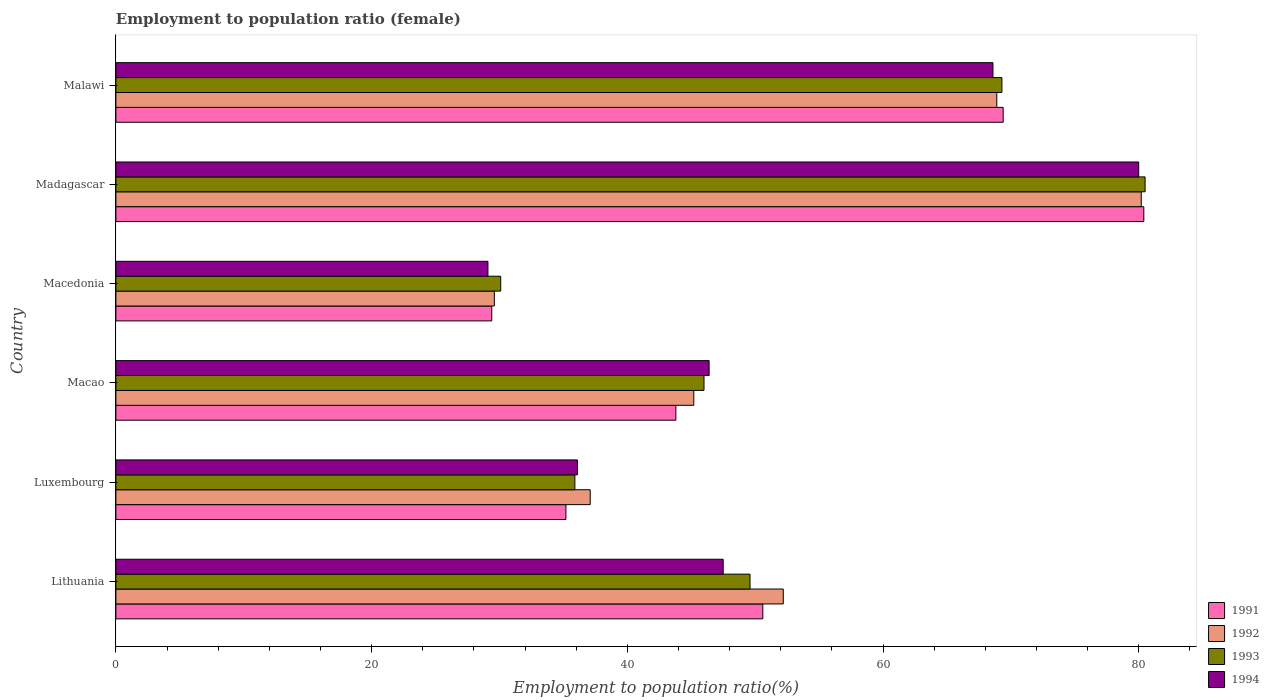How many different coloured bars are there?
Offer a terse response. 4. What is the label of the 1st group of bars from the top?
Offer a terse response. Malawi. In how many cases, is the number of bars for a given country not equal to the number of legend labels?
Provide a succinct answer. 0. What is the employment to population ratio in 1993 in Luxembourg?
Provide a short and direct response. 35.9. Across all countries, what is the maximum employment to population ratio in 1994?
Give a very brief answer. 80. Across all countries, what is the minimum employment to population ratio in 1993?
Provide a short and direct response. 30.1. In which country was the employment to population ratio in 1994 maximum?
Your response must be concise. Madagascar. In which country was the employment to population ratio in 1994 minimum?
Your response must be concise. Macedonia. What is the total employment to population ratio in 1991 in the graph?
Your answer should be compact. 308.8. What is the difference between the employment to population ratio in 1994 in Lithuania and that in Luxembourg?
Make the answer very short. 11.4. What is the difference between the employment to population ratio in 1992 in Macao and the employment to population ratio in 1991 in Luxembourg?
Give a very brief answer. 10. What is the average employment to population ratio in 1991 per country?
Ensure brevity in your answer.  51.47. What is the difference between the employment to population ratio in 1993 and employment to population ratio in 1992 in Madagascar?
Provide a short and direct response. 0.3. In how many countries, is the employment to population ratio in 1994 greater than 28 %?
Offer a terse response. 6. What is the ratio of the employment to population ratio in 1993 in Macao to that in Madagascar?
Give a very brief answer. 0.57. What is the difference between the highest and the second highest employment to population ratio in 1994?
Keep it short and to the point. 11.4. What is the difference between the highest and the lowest employment to population ratio in 1994?
Give a very brief answer. 50.9. Is the sum of the employment to population ratio in 1993 in Macao and Malawi greater than the maximum employment to population ratio in 1992 across all countries?
Give a very brief answer. Yes. Is it the case that in every country, the sum of the employment to population ratio in 1992 and employment to population ratio in 1993 is greater than the sum of employment to population ratio in 1994 and employment to population ratio in 1991?
Make the answer very short. No. Is it the case that in every country, the sum of the employment to population ratio in 1991 and employment to population ratio in 1994 is greater than the employment to population ratio in 1992?
Provide a succinct answer. Yes. How many bars are there?
Give a very brief answer. 24. Are all the bars in the graph horizontal?
Keep it short and to the point. Yes. How many countries are there in the graph?
Ensure brevity in your answer.  6. Are the values on the major ticks of X-axis written in scientific E-notation?
Your answer should be compact. No. Does the graph contain any zero values?
Offer a terse response. No. Does the graph contain grids?
Keep it short and to the point. No. What is the title of the graph?
Make the answer very short. Employment to population ratio (female). What is the Employment to population ratio(%) in 1991 in Lithuania?
Your response must be concise. 50.6. What is the Employment to population ratio(%) of 1992 in Lithuania?
Your response must be concise. 52.2. What is the Employment to population ratio(%) in 1993 in Lithuania?
Keep it short and to the point. 49.6. What is the Employment to population ratio(%) of 1994 in Lithuania?
Make the answer very short. 47.5. What is the Employment to population ratio(%) in 1991 in Luxembourg?
Keep it short and to the point. 35.2. What is the Employment to population ratio(%) of 1992 in Luxembourg?
Provide a short and direct response. 37.1. What is the Employment to population ratio(%) in 1993 in Luxembourg?
Make the answer very short. 35.9. What is the Employment to population ratio(%) of 1994 in Luxembourg?
Your answer should be very brief. 36.1. What is the Employment to population ratio(%) of 1991 in Macao?
Ensure brevity in your answer.  43.8. What is the Employment to population ratio(%) in 1992 in Macao?
Your answer should be compact. 45.2. What is the Employment to population ratio(%) of 1993 in Macao?
Ensure brevity in your answer.  46. What is the Employment to population ratio(%) in 1994 in Macao?
Ensure brevity in your answer.  46.4. What is the Employment to population ratio(%) in 1991 in Macedonia?
Provide a succinct answer. 29.4. What is the Employment to population ratio(%) in 1992 in Macedonia?
Your answer should be compact. 29.6. What is the Employment to population ratio(%) of 1993 in Macedonia?
Give a very brief answer. 30.1. What is the Employment to population ratio(%) of 1994 in Macedonia?
Make the answer very short. 29.1. What is the Employment to population ratio(%) in 1991 in Madagascar?
Offer a very short reply. 80.4. What is the Employment to population ratio(%) of 1992 in Madagascar?
Your response must be concise. 80.2. What is the Employment to population ratio(%) of 1993 in Madagascar?
Provide a short and direct response. 80.5. What is the Employment to population ratio(%) of 1994 in Madagascar?
Provide a short and direct response. 80. What is the Employment to population ratio(%) of 1991 in Malawi?
Make the answer very short. 69.4. What is the Employment to population ratio(%) in 1992 in Malawi?
Offer a very short reply. 68.9. What is the Employment to population ratio(%) of 1993 in Malawi?
Provide a succinct answer. 69.3. What is the Employment to population ratio(%) in 1994 in Malawi?
Give a very brief answer. 68.6. Across all countries, what is the maximum Employment to population ratio(%) of 1991?
Offer a very short reply. 80.4. Across all countries, what is the maximum Employment to population ratio(%) of 1992?
Ensure brevity in your answer.  80.2. Across all countries, what is the maximum Employment to population ratio(%) in 1993?
Your response must be concise. 80.5. Across all countries, what is the minimum Employment to population ratio(%) of 1991?
Your response must be concise. 29.4. Across all countries, what is the minimum Employment to population ratio(%) of 1992?
Your answer should be compact. 29.6. Across all countries, what is the minimum Employment to population ratio(%) in 1993?
Your answer should be very brief. 30.1. Across all countries, what is the minimum Employment to population ratio(%) of 1994?
Keep it short and to the point. 29.1. What is the total Employment to population ratio(%) in 1991 in the graph?
Provide a succinct answer. 308.8. What is the total Employment to population ratio(%) in 1992 in the graph?
Give a very brief answer. 313.2. What is the total Employment to population ratio(%) of 1993 in the graph?
Offer a very short reply. 311.4. What is the total Employment to population ratio(%) in 1994 in the graph?
Give a very brief answer. 307.7. What is the difference between the Employment to population ratio(%) of 1991 in Lithuania and that in Luxembourg?
Provide a succinct answer. 15.4. What is the difference between the Employment to population ratio(%) of 1994 in Lithuania and that in Luxembourg?
Your answer should be compact. 11.4. What is the difference between the Employment to population ratio(%) of 1992 in Lithuania and that in Macao?
Offer a very short reply. 7. What is the difference between the Employment to population ratio(%) of 1991 in Lithuania and that in Macedonia?
Your answer should be very brief. 21.2. What is the difference between the Employment to population ratio(%) of 1992 in Lithuania and that in Macedonia?
Offer a very short reply. 22.6. What is the difference between the Employment to population ratio(%) in 1993 in Lithuania and that in Macedonia?
Offer a very short reply. 19.5. What is the difference between the Employment to population ratio(%) of 1994 in Lithuania and that in Macedonia?
Keep it short and to the point. 18.4. What is the difference between the Employment to population ratio(%) in 1991 in Lithuania and that in Madagascar?
Keep it short and to the point. -29.8. What is the difference between the Employment to population ratio(%) of 1993 in Lithuania and that in Madagascar?
Offer a very short reply. -30.9. What is the difference between the Employment to population ratio(%) of 1994 in Lithuania and that in Madagascar?
Keep it short and to the point. -32.5. What is the difference between the Employment to population ratio(%) of 1991 in Lithuania and that in Malawi?
Offer a very short reply. -18.8. What is the difference between the Employment to population ratio(%) in 1992 in Lithuania and that in Malawi?
Provide a short and direct response. -16.7. What is the difference between the Employment to population ratio(%) in 1993 in Lithuania and that in Malawi?
Provide a short and direct response. -19.7. What is the difference between the Employment to population ratio(%) of 1994 in Lithuania and that in Malawi?
Ensure brevity in your answer.  -21.1. What is the difference between the Employment to population ratio(%) of 1992 in Luxembourg and that in Macao?
Make the answer very short. -8.1. What is the difference between the Employment to population ratio(%) in 1993 in Luxembourg and that in Macao?
Ensure brevity in your answer.  -10.1. What is the difference between the Employment to population ratio(%) of 1994 in Luxembourg and that in Macao?
Ensure brevity in your answer.  -10.3. What is the difference between the Employment to population ratio(%) in 1991 in Luxembourg and that in Macedonia?
Your answer should be compact. 5.8. What is the difference between the Employment to population ratio(%) in 1991 in Luxembourg and that in Madagascar?
Provide a short and direct response. -45.2. What is the difference between the Employment to population ratio(%) in 1992 in Luxembourg and that in Madagascar?
Your answer should be very brief. -43.1. What is the difference between the Employment to population ratio(%) in 1993 in Luxembourg and that in Madagascar?
Your answer should be very brief. -44.6. What is the difference between the Employment to population ratio(%) of 1994 in Luxembourg and that in Madagascar?
Ensure brevity in your answer.  -43.9. What is the difference between the Employment to population ratio(%) of 1991 in Luxembourg and that in Malawi?
Your answer should be very brief. -34.2. What is the difference between the Employment to population ratio(%) in 1992 in Luxembourg and that in Malawi?
Give a very brief answer. -31.8. What is the difference between the Employment to population ratio(%) in 1993 in Luxembourg and that in Malawi?
Offer a terse response. -33.4. What is the difference between the Employment to population ratio(%) of 1994 in Luxembourg and that in Malawi?
Your answer should be very brief. -32.5. What is the difference between the Employment to population ratio(%) in 1994 in Macao and that in Macedonia?
Offer a very short reply. 17.3. What is the difference between the Employment to population ratio(%) of 1991 in Macao and that in Madagascar?
Your response must be concise. -36.6. What is the difference between the Employment to population ratio(%) in 1992 in Macao and that in Madagascar?
Provide a succinct answer. -35. What is the difference between the Employment to population ratio(%) of 1993 in Macao and that in Madagascar?
Your answer should be compact. -34.5. What is the difference between the Employment to population ratio(%) in 1994 in Macao and that in Madagascar?
Your answer should be compact. -33.6. What is the difference between the Employment to population ratio(%) in 1991 in Macao and that in Malawi?
Your response must be concise. -25.6. What is the difference between the Employment to population ratio(%) of 1992 in Macao and that in Malawi?
Give a very brief answer. -23.7. What is the difference between the Employment to population ratio(%) of 1993 in Macao and that in Malawi?
Make the answer very short. -23.3. What is the difference between the Employment to population ratio(%) in 1994 in Macao and that in Malawi?
Make the answer very short. -22.2. What is the difference between the Employment to population ratio(%) in 1991 in Macedonia and that in Madagascar?
Provide a short and direct response. -51. What is the difference between the Employment to population ratio(%) in 1992 in Macedonia and that in Madagascar?
Provide a short and direct response. -50.6. What is the difference between the Employment to population ratio(%) of 1993 in Macedonia and that in Madagascar?
Give a very brief answer. -50.4. What is the difference between the Employment to population ratio(%) in 1994 in Macedonia and that in Madagascar?
Give a very brief answer. -50.9. What is the difference between the Employment to population ratio(%) of 1991 in Macedonia and that in Malawi?
Make the answer very short. -40. What is the difference between the Employment to population ratio(%) in 1992 in Macedonia and that in Malawi?
Ensure brevity in your answer.  -39.3. What is the difference between the Employment to population ratio(%) of 1993 in Macedonia and that in Malawi?
Give a very brief answer. -39.2. What is the difference between the Employment to population ratio(%) in 1994 in Macedonia and that in Malawi?
Your response must be concise. -39.5. What is the difference between the Employment to population ratio(%) of 1992 in Madagascar and that in Malawi?
Provide a short and direct response. 11.3. What is the difference between the Employment to population ratio(%) of 1994 in Madagascar and that in Malawi?
Provide a short and direct response. 11.4. What is the difference between the Employment to population ratio(%) of 1991 in Lithuania and the Employment to population ratio(%) of 1992 in Luxembourg?
Ensure brevity in your answer.  13.5. What is the difference between the Employment to population ratio(%) in 1991 in Lithuania and the Employment to population ratio(%) in 1993 in Luxembourg?
Your answer should be very brief. 14.7. What is the difference between the Employment to population ratio(%) of 1992 in Lithuania and the Employment to population ratio(%) of 1993 in Luxembourg?
Your answer should be very brief. 16.3. What is the difference between the Employment to population ratio(%) of 1992 in Lithuania and the Employment to population ratio(%) of 1994 in Luxembourg?
Offer a terse response. 16.1. What is the difference between the Employment to population ratio(%) of 1993 in Lithuania and the Employment to population ratio(%) of 1994 in Luxembourg?
Give a very brief answer. 13.5. What is the difference between the Employment to population ratio(%) in 1991 in Lithuania and the Employment to population ratio(%) in 1992 in Macao?
Ensure brevity in your answer.  5.4. What is the difference between the Employment to population ratio(%) of 1991 in Lithuania and the Employment to population ratio(%) of 1993 in Macao?
Make the answer very short. 4.6. What is the difference between the Employment to population ratio(%) of 1991 in Lithuania and the Employment to population ratio(%) of 1994 in Macao?
Ensure brevity in your answer.  4.2. What is the difference between the Employment to population ratio(%) of 1992 in Lithuania and the Employment to population ratio(%) of 1993 in Macao?
Ensure brevity in your answer.  6.2. What is the difference between the Employment to population ratio(%) of 1993 in Lithuania and the Employment to population ratio(%) of 1994 in Macao?
Provide a short and direct response. 3.2. What is the difference between the Employment to population ratio(%) in 1991 in Lithuania and the Employment to population ratio(%) in 1994 in Macedonia?
Keep it short and to the point. 21.5. What is the difference between the Employment to population ratio(%) of 1992 in Lithuania and the Employment to population ratio(%) of 1993 in Macedonia?
Give a very brief answer. 22.1. What is the difference between the Employment to population ratio(%) in 1992 in Lithuania and the Employment to population ratio(%) in 1994 in Macedonia?
Ensure brevity in your answer.  23.1. What is the difference between the Employment to population ratio(%) in 1991 in Lithuania and the Employment to population ratio(%) in 1992 in Madagascar?
Your answer should be compact. -29.6. What is the difference between the Employment to population ratio(%) in 1991 in Lithuania and the Employment to population ratio(%) in 1993 in Madagascar?
Your response must be concise. -29.9. What is the difference between the Employment to population ratio(%) in 1991 in Lithuania and the Employment to population ratio(%) in 1994 in Madagascar?
Provide a short and direct response. -29.4. What is the difference between the Employment to population ratio(%) of 1992 in Lithuania and the Employment to population ratio(%) of 1993 in Madagascar?
Offer a terse response. -28.3. What is the difference between the Employment to population ratio(%) in 1992 in Lithuania and the Employment to population ratio(%) in 1994 in Madagascar?
Provide a succinct answer. -27.8. What is the difference between the Employment to population ratio(%) of 1993 in Lithuania and the Employment to population ratio(%) of 1994 in Madagascar?
Offer a very short reply. -30.4. What is the difference between the Employment to population ratio(%) in 1991 in Lithuania and the Employment to population ratio(%) in 1992 in Malawi?
Give a very brief answer. -18.3. What is the difference between the Employment to population ratio(%) of 1991 in Lithuania and the Employment to population ratio(%) of 1993 in Malawi?
Offer a very short reply. -18.7. What is the difference between the Employment to population ratio(%) of 1991 in Lithuania and the Employment to population ratio(%) of 1994 in Malawi?
Offer a terse response. -18. What is the difference between the Employment to population ratio(%) in 1992 in Lithuania and the Employment to population ratio(%) in 1993 in Malawi?
Your answer should be very brief. -17.1. What is the difference between the Employment to population ratio(%) of 1992 in Lithuania and the Employment to population ratio(%) of 1994 in Malawi?
Give a very brief answer. -16.4. What is the difference between the Employment to population ratio(%) in 1993 in Lithuania and the Employment to population ratio(%) in 1994 in Malawi?
Your response must be concise. -19. What is the difference between the Employment to population ratio(%) in 1991 in Luxembourg and the Employment to population ratio(%) in 1993 in Macao?
Your answer should be very brief. -10.8. What is the difference between the Employment to population ratio(%) in 1991 in Luxembourg and the Employment to population ratio(%) in 1994 in Macao?
Your answer should be very brief. -11.2. What is the difference between the Employment to population ratio(%) in 1992 in Luxembourg and the Employment to population ratio(%) in 1993 in Macao?
Keep it short and to the point. -8.9. What is the difference between the Employment to population ratio(%) in 1991 in Luxembourg and the Employment to population ratio(%) in 1992 in Macedonia?
Give a very brief answer. 5.6. What is the difference between the Employment to population ratio(%) in 1991 in Luxembourg and the Employment to population ratio(%) in 1993 in Macedonia?
Offer a very short reply. 5.1. What is the difference between the Employment to population ratio(%) of 1991 in Luxembourg and the Employment to population ratio(%) of 1994 in Macedonia?
Give a very brief answer. 6.1. What is the difference between the Employment to population ratio(%) in 1992 in Luxembourg and the Employment to population ratio(%) in 1994 in Macedonia?
Make the answer very short. 8. What is the difference between the Employment to population ratio(%) of 1991 in Luxembourg and the Employment to population ratio(%) of 1992 in Madagascar?
Offer a terse response. -45. What is the difference between the Employment to population ratio(%) of 1991 in Luxembourg and the Employment to population ratio(%) of 1993 in Madagascar?
Provide a succinct answer. -45.3. What is the difference between the Employment to population ratio(%) in 1991 in Luxembourg and the Employment to population ratio(%) in 1994 in Madagascar?
Ensure brevity in your answer.  -44.8. What is the difference between the Employment to population ratio(%) of 1992 in Luxembourg and the Employment to population ratio(%) of 1993 in Madagascar?
Offer a very short reply. -43.4. What is the difference between the Employment to population ratio(%) of 1992 in Luxembourg and the Employment to population ratio(%) of 1994 in Madagascar?
Provide a succinct answer. -42.9. What is the difference between the Employment to population ratio(%) in 1993 in Luxembourg and the Employment to population ratio(%) in 1994 in Madagascar?
Keep it short and to the point. -44.1. What is the difference between the Employment to population ratio(%) in 1991 in Luxembourg and the Employment to population ratio(%) in 1992 in Malawi?
Give a very brief answer. -33.7. What is the difference between the Employment to population ratio(%) in 1991 in Luxembourg and the Employment to population ratio(%) in 1993 in Malawi?
Provide a short and direct response. -34.1. What is the difference between the Employment to population ratio(%) in 1991 in Luxembourg and the Employment to population ratio(%) in 1994 in Malawi?
Offer a very short reply. -33.4. What is the difference between the Employment to population ratio(%) of 1992 in Luxembourg and the Employment to population ratio(%) of 1993 in Malawi?
Ensure brevity in your answer.  -32.2. What is the difference between the Employment to population ratio(%) of 1992 in Luxembourg and the Employment to population ratio(%) of 1994 in Malawi?
Ensure brevity in your answer.  -31.5. What is the difference between the Employment to population ratio(%) of 1993 in Luxembourg and the Employment to population ratio(%) of 1994 in Malawi?
Provide a succinct answer. -32.7. What is the difference between the Employment to population ratio(%) of 1991 in Macao and the Employment to population ratio(%) of 1992 in Macedonia?
Offer a terse response. 14.2. What is the difference between the Employment to population ratio(%) of 1991 in Macao and the Employment to population ratio(%) of 1994 in Macedonia?
Keep it short and to the point. 14.7. What is the difference between the Employment to population ratio(%) of 1992 in Macao and the Employment to population ratio(%) of 1993 in Macedonia?
Offer a terse response. 15.1. What is the difference between the Employment to population ratio(%) in 1993 in Macao and the Employment to population ratio(%) in 1994 in Macedonia?
Keep it short and to the point. 16.9. What is the difference between the Employment to population ratio(%) of 1991 in Macao and the Employment to population ratio(%) of 1992 in Madagascar?
Offer a terse response. -36.4. What is the difference between the Employment to population ratio(%) of 1991 in Macao and the Employment to population ratio(%) of 1993 in Madagascar?
Provide a short and direct response. -36.7. What is the difference between the Employment to population ratio(%) of 1991 in Macao and the Employment to population ratio(%) of 1994 in Madagascar?
Your response must be concise. -36.2. What is the difference between the Employment to population ratio(%) in 1992 in Macao and the Employment to population ratio(%) in 1993 in Madagascar?
Make the answer very short. -35.3. What is the difference between the Employment to population ratio(%) of 1992 in Macao and the Employment to population ratio(%) of 1994 in Madagascar?
Offer a very short reply. -34.8. What is the difference between the Employment to population ratio(%) of 1993 in Macao and the Employment to population ratio(%) of 1994 in Madagascar?
Provide a short and direct response. -34. What is the difference between the Employment to population ratio(%) in 1991 in Macao and the Employment to population ratio(%) in 1992 in Malawi?
Provide a short and direct response. -25.1. What is the difference between the Employment to population ratio(%) in 1991 in Macao and the Employment to population ratio(%) in 1993 in Malawi?
Make the answer very short. -25.5. What is the difference between the Employment to population ratio(%) in 1991 in Macao and the Employment to population ratio(%) in 1994 in Malawi?
Provide a short and direct response. -24.8. What is the difference between the Employment to population ratio(%) of 1992 in Macao and the Employment to population ratio(%) of 1993 in Malawi?
Your response must be concise. -24.1. What is the difference between the Employment to population ratio(%) in 1992 in Macao and the Employment to population ratio(%) in 1994 in Malawi?
Your answer should be very brief. -23.4. What is the difference between the Employment to population ratio(%) in 1993 in Macao and the Employment to population ratio(%) in 1994 in Malawi?
Make the answer very short. -22.6. What is the difference between the Employment to population ratio(%) of 1991 in Macedonia and the Employment to population ratio(%) of 1992 in Madagascar?
Keep it short and to the point. -50.8. What is the difference between the Employment to population ratio(%) of 1991 in Macedonia and the Employment to population ratio(%) of 1993 in Madagascar?
Your answer should be compact. -51.1. What is the difference between the Employment to population ratio(%) of 1991 in Macedonia and the Employment to population ratio(%) of 1994 in Madagascar?
Give a very brief answer. -50.6. What is the difference between the Employment to population ratio(%) in 1992 in Macedonia and the Employment to population ratio(%) in 1993 in Madagascar?
Provide a succinct answer. -50.9. What is the difference between the Employment to population ratio(%) in 1992 in Macedonia and the Employment to population ratio(%) in 1994 in Madagascar?
Provide a short and direct response. -50.4. What is the difference between the Employment to population ratio(%) in 1993 in Macedonia and the Employment to population ratio(%) in 1994 in Madagascar?
Your answer should be very brief. -49.9. What is the difference between the Employment to population ratio(%) of 1991 in Macedonia and the Employment to population ratio(%) of 1992 in Malawi?
Offer a very short reply. -39.5. What is the difference between the Employment to population ratio(%) in 1991 in Macedonia and the Employment to population ratio(%) in 1993 in Malawi?
Ensure brevity in your answer.  -39.9. What is the difference between the Employment to population ratio(%) of 1991 in Macedonia and the Employment to population ratio(%) of 1994 in Malawi?
Give a very brief answer. -39.2. What is the difference between the Employment to population ratio(%) in 1992 in Macedonia and the Employment to population ratio(%) in 1993 in Malawi?
Your answer should be compact. -39.7. What is the difference between the Employment to population ratio(%) of 1992 in Macedonia and the Employment to population ratio(%) of 1994 in Malawi?
Provide a succinct answer. -39. What is the difference between the Employment to population ratio(%) of 1993 in Macedonia and the Employment to population ratio(%) of 1994 in Malawi?
Make the answer very short. -38.5. What is the difference between the Employment to population ratio(%) of 1991 in Madagascar and the Employment to population ratio(%) of 1992 in Malawi?
Your answer should be very brief. 11.5. What is the difference between the Employment to population ratio(%) of 1992 in Madagascar and the Employment to population ratio(%) of 1993 in Malawi?
Offer a terse response. 10.9. What is the difference between the Employment to population ratio(%) of 1992 in Madagascar and the Employment to population ratio(%) of 1994 in Malawi?
Keep it short and to the point. 11.6. What is the difference between the Employment to population ratio(%) in 1993 in Madagascar and the Employment to population ratio(%) in 1994 in Malawi?
Give a very brief answer. 11.9. What is the average Employment to population ratio(%) of 1991 per country?
Keep it short and to the point. 51.47. What is the average Employment to population ratio(%) of 1992 per country?
Offer a very short reply. 52.2. What is the average Employment to population ratio(%) of 1993 per country?
Provide a succinct answer. 51.9. What is the average Employment to population ratio(%) in 1994 per country?
Offer a very short reply. 51.28. What is the difference between the Employment to population ratio(%) of 1991 and Employment to population ratio(%) of 1993 in Lithuania?
Make the answer very short. 1. What is the difference between the Employment to population ratio(%) in 1992 and Employment to population ratio(%) in 1993 in Lithuania?
Offer a terse response. 2.6. What is the difference between the Employment to population ratio(%) of 1992 and Employment to population ratio(%) of 1994 in Lithuania?
Provide a succinct answer. 4.7. What is the difference between the Employment to population ratio(%) in 1991 and Employment to population ratio(%) in 1992 in Luxembourg?
Provide a succinct answer. -1.9. What is the difference between the Employment to population ratio(%) in 1991 and Employment to population ratio(%) in 1994 in Luxembourg?
Provide a short and direct response. -0.9. What is the difference between the Employment to population ratio(%) of 1993 and Employment to population ratio(%) of 1994 in Luxembourg?
Keep it short and to the point. -0.2. What is the difference between the Employment to population ratio(%) of 1992 and Employment to population ratio(%) of 1993 in Macao?
Ensure brevity in your answer.  -0.8. What is the difference between the Employment to population ratio(%) in 1993 and Employment to population ratio(%) in 1994 in Macao?
Keep it short and to the point. -0.4. What is the difference between the Employment to population ratio(%) in 1991 and Employment to population ratio(%) in 1992 in Macedonia?
Offer a terse response. -0.2. What is the difference between the Employment to population ratio(%) of 1991 and Employment to population ratio(%) of 1993 in Macedonia?
Ensure brevity in your answer.  -0.7. What is the difference between the Employment to population ratio(%) in 1991 and Employment to population ratio(%) in 1994 in Macedonia?
Keep it short and to the point. 0.3. What is the difference between the Employment to population ratio(%) of 1992 and Employment to population ratio(%) of 1993 in Macedonia?
Your response must be concise. -0.5. What is the difference between the Employment to population ratio(%) of 1992 and Employment to population ratio(%) of 1994 in Macedonia?
Ensure brevity in your answer.  0.5. What is the difference between the Employment to population ratio(%) of 1993 and Employment to population ratio(%) of 1994 in Macedonia?
Offer a very short reply. 1. What is the difference between the Employment to population ratio(%) in 1991 and Employment to population ratio(%) in 1992 in Madagascar?
Ensure brevity in your answer.  0.2. What is the difference between the Employment to population ratio(%) of 1991 and Employment to population ratio(%) of 1994 in Madagascar?
Your response must be concise. 0.4. What is the difference between the Employment to population ratio(%) of 1992 and Employment to population ratio(%) of 1993 in Madagascar?
Your answer should be compact. -0.3. What is the difference between the Employment to population ratio(%) in 1993 and Employment to population ratio(%) in 1994 in Madagascar?
Make the answer very short. 0.5. What is the difference between the Employment to population ratio(%) of 1991 and Employment to population ratio(%) of 1993 in Malawi?
Your answer should be very brief. 0.1. What is the difference between the Employment to population ratio(%) of 1991 and Employment to population ratio(%) of 1994 in Malawi?
Give a very brief answer. 0.8. What is the difference between the Employment to population ratio(%) of 1993 and Employment to population ratio(%) of 1994 in Malawi?
Your response must be concise. 0.7. What is the ratio of the Employment to population ratio(%) of 1991 in Lithuania to that in Luxembourg?
Provide a short and direct response. 1.44. What is the ratio of the Employment to population ratio(%) in 1992 in Lithuania to that in Luxembourg?
Provide a short and direct response. 1.41. What is the ratio of the Employment to population ratio(%) in 1993 in Lithuania to that in Luxembourg?
Your response must be concise. 1.38. What is the ratio of the Employment to population ratio(%) in 1994 in Lithuania to that in Luxembourg?
Provide a short and direct response. 1.32. What is the ratio of the Employment to population ratio(%) of 1991 in Lithuania to that in Macao?
Your answer should be very brief. 1.16. What is the ratio of the Employment to population ratio(%) in 1992 in Lithuania to that in Macao?
Give a very brief answer. 1.15. What is the ratio of the Employment to population ratio(%) of 1993 in Lithuania to that in Macao?
Make the answer very short. 1.08. What is the ratio of the Employment to population ratio(%) in 1994 in Lithuania to that in Macao?
Give a very brief answer. 1.02. What is the ratio of the Employment to population ratio(%) in 1991 in Lithuania to that in Macedonia?
Give a very brief answer. 1.72. What is the ratio of the Employment to population ratio(%) of 1992 in Lithuania to that in Macedonia?
Offer a terse response. 1.76. What is the ratio of the Employment to population ratio(%) of 1993 in Lithuania to that in Macedonia?
Make the answer very short. 1.65. What is the ratio of the Employment to population ratio(%) of 1994 in Lithuania to that in Macedonia?
Ensure brevity in your answer.  1.63. What is the ratio of the Employment to population ratio(%) of 1991 in Lithuania to that in Madagascar?
Offer a terse response. 0.63. What is the ratio of the Employment to population ratio(%) in 1992 in Lithuania to that in Madagascar?
Keep it short and to the point. 0.65. What is the ratio of the Employment to population ratio(%) of 1993 in Lithuania to that in Madagascar?
Your response must be concise. 0.62. What is the ratio of the Employment to population ratio(%) in 1994 in Lithuania to that in Madagascar?
Offer a very short reply. 0.59. What is the ratio of the Employment to population ratio(%) in 1991 in Lithuania to that in Malawi?
Your response must be concise. 0.73. What is the ratio of the Employment to population ratio(%) in 1992 in Lithuania to that in Malawi?
Keep it short and to the point. 0.76. What is the ratio of the Employment to population ratio(%) in 1993 in Lithuania to that in Malawi?
Give a very brief answer. 0.72. What is the ratio of the Employment to population ratio(%) in 1994 in Lithuania to that in Malawi?
Keep it short and to the point. 0.69. What is the ratio of the Employment to population ratio(%) in 1991 in Luxembourg to that in Macao?
Offer a very short reply. 0.8. What is the ratio of the Employment to population ratio(%) in 1992 in Luxembourg to that in Macao?
Offer a very short reply. 0.82. What is the ratio of the Employment to population ratio(%) of 1993 in Luxembourg to that in Macao?
Your answer should be compact. 0.78. What is the ratio of the Employment to population ratio(%) of 1994 in Luxembourg to that in Macao?
Ensure brevity in your answer.  0.78. What is the ratio of the Employment to population ratio(%) of 1991 in Luxembourg to that in Macedonia?
Your answer should be compact. 1.2. What is the ratio of the Employment to population ratio(%) in 1992 in Luxembourg to that in Macedonia?
Your answer should be compact. 1.25. What is the ratio of the Employment to population ratio(%) of 1993 in Luxembourg to that in Macedonia?
Your answer should be very brief. 1.19. What is the ratio of the Employment to population ratio(%) of 1994 in Luxembourg to that in Macedonia?
Your answer should be very brief. 1.24. What is the ratio of the Employment to population ratio(%) of 1991 in Luxembourg to that in Madagascar?
Offer a terse response. 0.44. What is the ratio of the Employment to population ratio(%) in 1992 in Luxembourg to that in Madagascar?
Provide a short and direct response. 0.46. What is the ratio of the Employment to population ratio(%) in 1993 in Luxembourg to that in Madagascar?
Your answer should be very brief. 0.45. What is the ratio of the Employment to population ratio(%) of 1994 in Luxembourg to that in Madagascar?
Make the answer very short. 0.45. What is the ratio of the Employment to population ratio(%) of 1991 in Luxembourg to that in Malawi?
Ensure brevity in your answer.  0.51. What is the ratio of the Employment to population ratio(%) of 1992 in Luxembourg to that in Malawi?
Keep it short and to the point. 0.54. What is the ratio of the Employment to population ratio(%) of 1993 in Luxembourg to that in Malawi?
Keep it short and to the point. 0.52. What is the ratio of the Employment to population ratio(%) in 1994 in Luxembourg to that in Malawi?
Make the answer very short. 0.53. What is the ratio of the Employment to population ratio(%) in 1991 in Macao to that in Macedonia?
Your answer should be compact. 1.49. What is the ratio of the Employment to population ratio(%) of 1992 in Macao to that in Macedonia?
Provide a succinct answer. 1.53. What is the ratio of the Employment to population ratio(%) of 1993 in Macao to that in Macedonia?
Keep it short and to the point. 1.53. What is the ratio of the Employment to population ratio(%) of 1994 in Macao to that in Macedonia?
Your response must be concise. 1.59. What is the ratio of the Employment to population ratio(%) in 1991 in Macao to that in Madagascar?
Ensure brevity in your answer.  0.54. What is the ratio of the Employment to population ratio(%) of 1992 in Macao to that in Madagascar?
Your answer should be compact. 0.56. What is the ratio of the Employment to population ratio(%) of 1993 in Macao to that in Madagascar?
Your response must be concise. 0.57. What is the ratio of the Employment to population ratio(%) in 1994 in Macao to that in Madagascar?
Keep it short and to the point. 0.58. What is the ratio of the Employment to population ratio(%) of 1991 in Macao to that in Malawi?
Give a very brief answer. 0.63. What is the ratio of the Employment to population ratio(%) of 1992 in Macao to that in Malawi?
Make the answer very short. 0.66. What is the ratio of the Employment to population ratio(%) of 1993 in Macao to that in Malawi?
Your answer should be compact. 0.66. What is the ratio of the Employment to population ratio(%) in 1994 in Macao to that in Malawi?
Your response must be concise. 0.68. What is the ratio of the Employment to population ratio(%) in 1991 in Macedonia to that in Madagascar?
Offer a very short reply. 0.37. What is the ratio of the Employment to population ratio(%) in 1992 in Macedonia to that in Madagascar?
Provide a short and direct response. 0.37. What is the ratio of the Employment to population ratio(%) in 1993 in Macedonia to that in Madagascar?
Provide a short and direct response. 0.37. What is the ratio of the Employment to population ratio(%) of 1994 in Macedonia to that in Madagascar?
Give a very brief answer. 0.36. What is the ratio of the Employment to population ratio(%) of 1991 in Macedonia to that in Malawi?
Provide a short and direct response. 0.42. What is the ratio of the Employment to population ratio(%) of 1992 in Macedonia to that in Malawi?
Your response must be concise. 0.43. What is the ratio of the Employment to population ratio(%) of 1993 in Macedonia to that in Malawi?
Provide a short and direct response. 0.43. What is the ratio of the Employment to population ratio(%) of 1994 in Macedonia to that in Malawi?
Keep it short and to the point. 0.42. What is the ratio of the Employment to population ratio(%) in 1991 in Madagascar to that in Malawi?
Your response must be concise. 1.16. What is the ratio of the Employment to population ratio(%) of 1992 in Madagascar to that in Malawi?
Provide a succinct answer. 1.16. What is the ratio of the Employment to population ratio(%) of 1993 in Madagascar to that in Malawi?
Offer a terse response. 1.16. What is the ratio of the Employment to population ratio(%) in 1994 in Madagascar to that in Malawi?
Provide a short and direct response. 1.17. What is the difference between the highest and the second highest Employment to population ratio(%) of 1991?
Make the answer very short. 11. What is the difference between the highest and the second highest Employment to population ratio(%) in 1992?
Provide a succinct answer. 11.3. What is the difference between the highest and the second highest Employment to population ratio(%) in 1993?
Give a very brief answer. 11.2. What is the difference between the highest and the lowest Employment to population ratio(%) of 1992?
Your response must be concise. 50.6. What is the difference between the highest and the lowest Employment to population ratio(%) of 1993?
Give a very brief answer. 50.4. What is the difference between the highest and the lowest Employment to population ratio(%) of 1994?
Your answer should be compact. 50.9. 